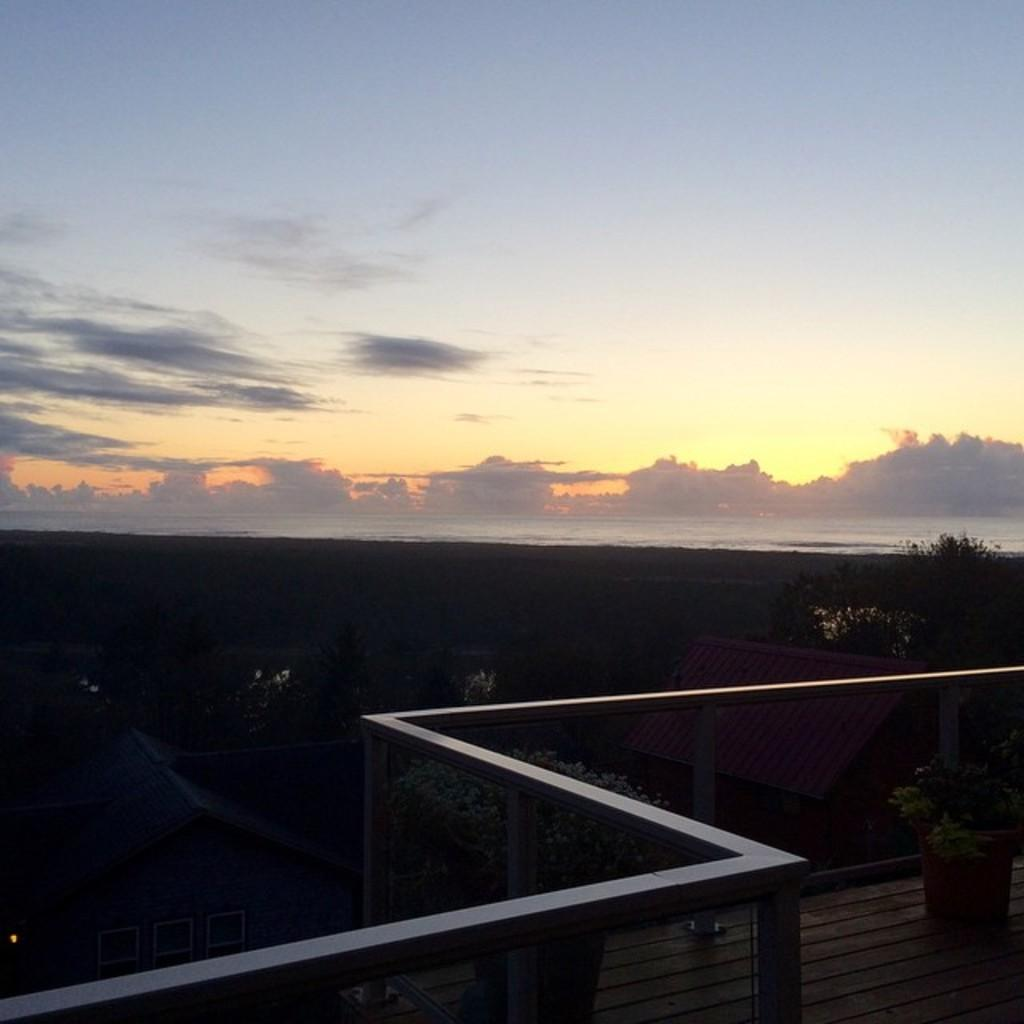What can be seen in the image that might be used for support or safety? There is a railing in the image that could be used for support or safety. What type of vegetation is present in the image? There are trees in the image. What color is the roof in the image? The roof in the image is red in color. What is visible in the background of the image? Water, more trees, and the sky are visible in the background of the image. Where are the eggs hidden in the image? There are no eggs present in the image. What type of bushes can be seen in the image? There is no mention of bushes in the provided facts, and therefore we cannot determine if they are present in the image. 